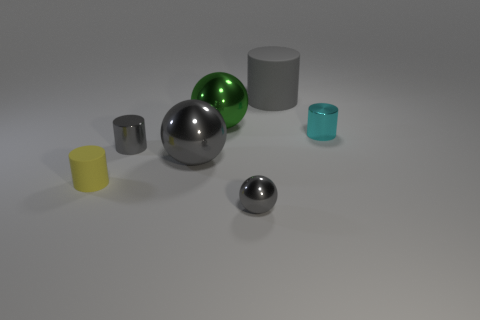There is a large sphere that is the same color as the small metallic sphere; what material is it?
Make the answer very short. Metal. What is the cyan cylinder made of?
Make the answer very short. Metal. Does the sphere in front of the small yellow cylinder have the same material as the small cyan thing?
Provide a succinct answer. Yes. The gray shiny object that is on the right side of the big green object has what shape?
Your answer should be compact. Sphere. There is a cylinder that is the same size as the green metal thing; what material is it?
Your answer should be compact. Rubber. How many things are metallic balls behind the tiny cyan shiny object or rubber things on the left side of the big green metallic thing?
Ensure brevity in your answer.  2. The gray cylinder that is the same material as the cyan cylinder is what size?
Your answer should be very brief. Small. How many metallic objects are either large cylinders or cyan objects?
Your answer should be very brief. 1. The gray matte thing is what size?
Ensure brevity in your answer.  Large. Does the green metallic sphere have the same size as the gray metal cylinder?
Your response must be concise. No. 